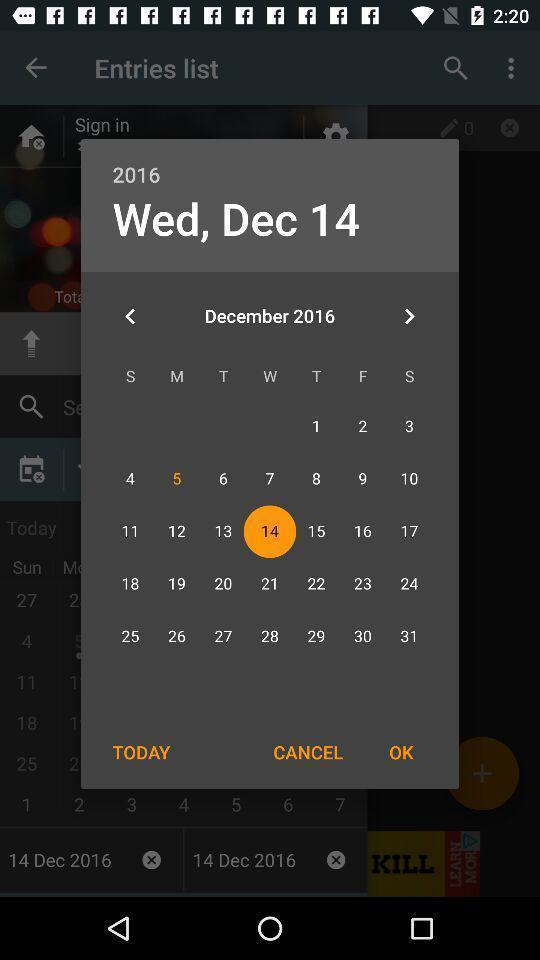Explain what's happening in this screen capture. Popup displaying calendar information about a diary application. 